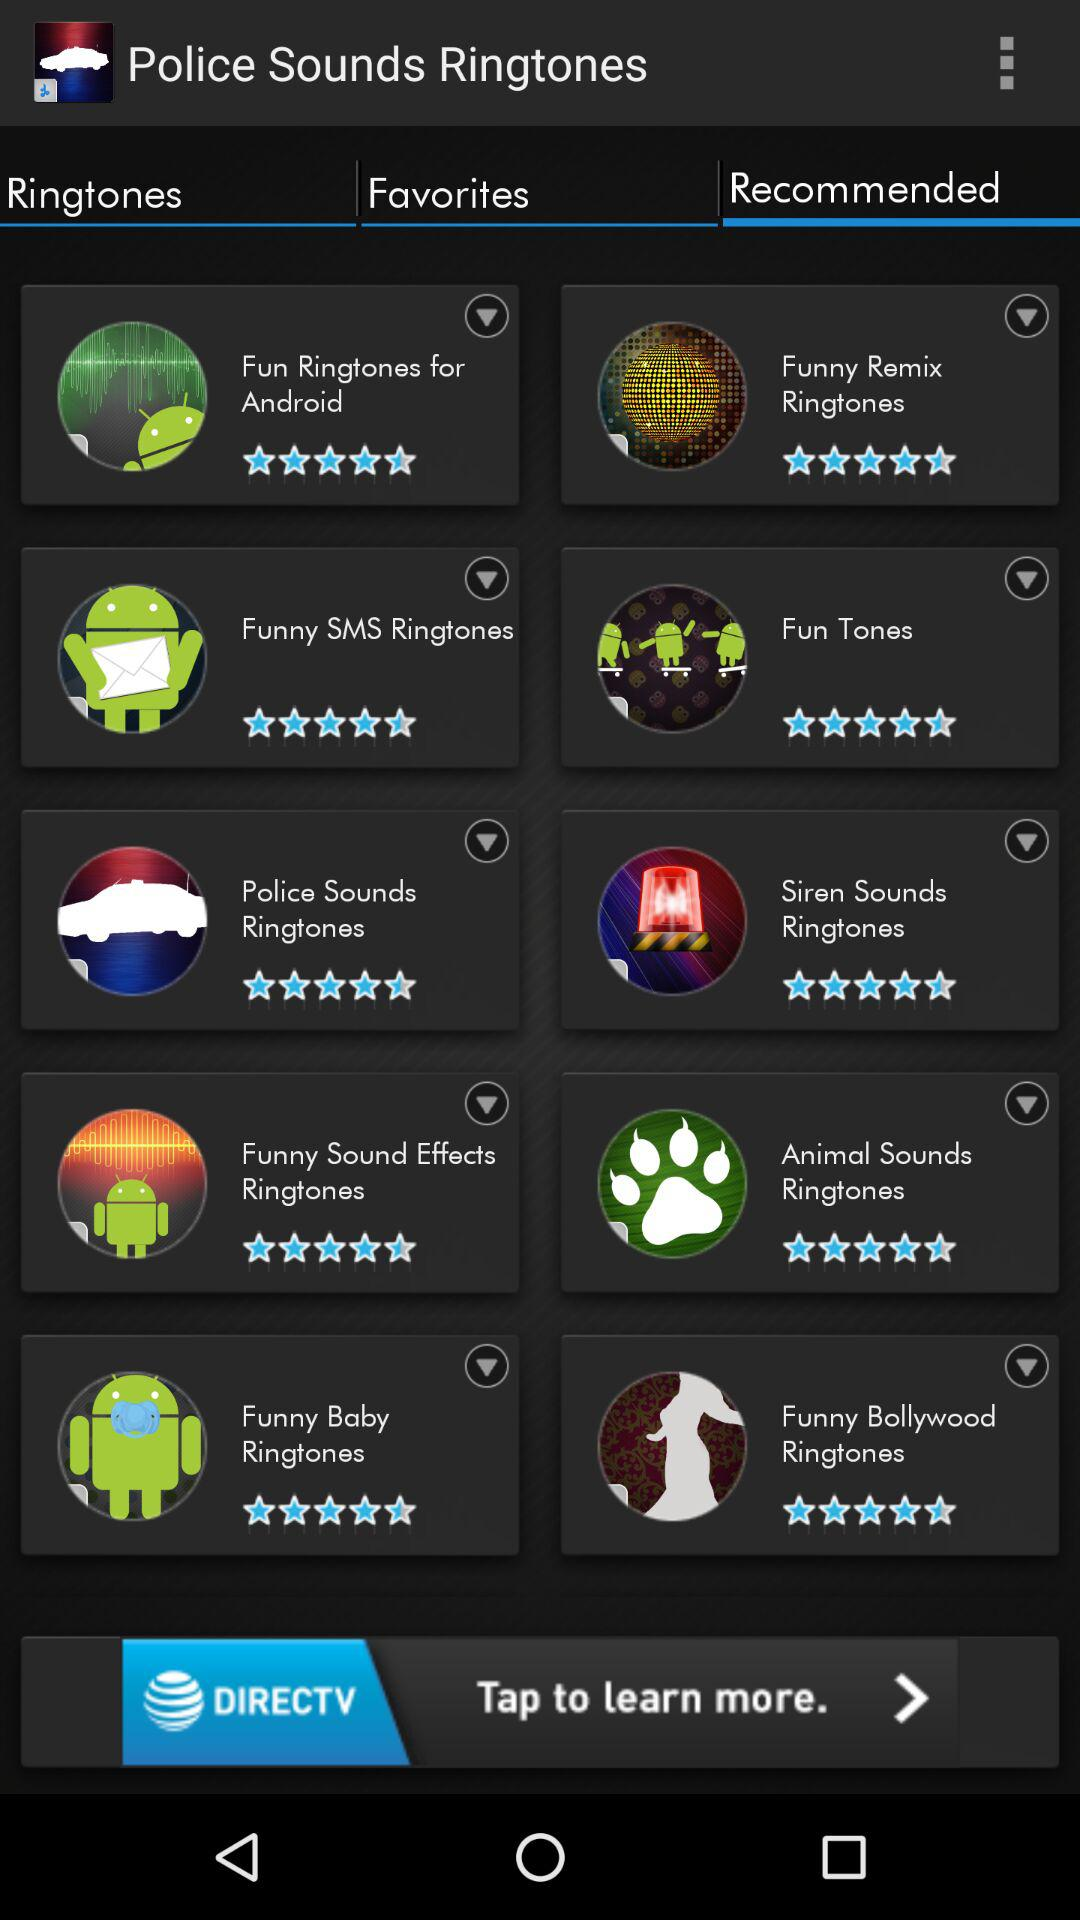What is the star rating given to "Funny SMS Ringtones"? The given star rating is 4.5. 